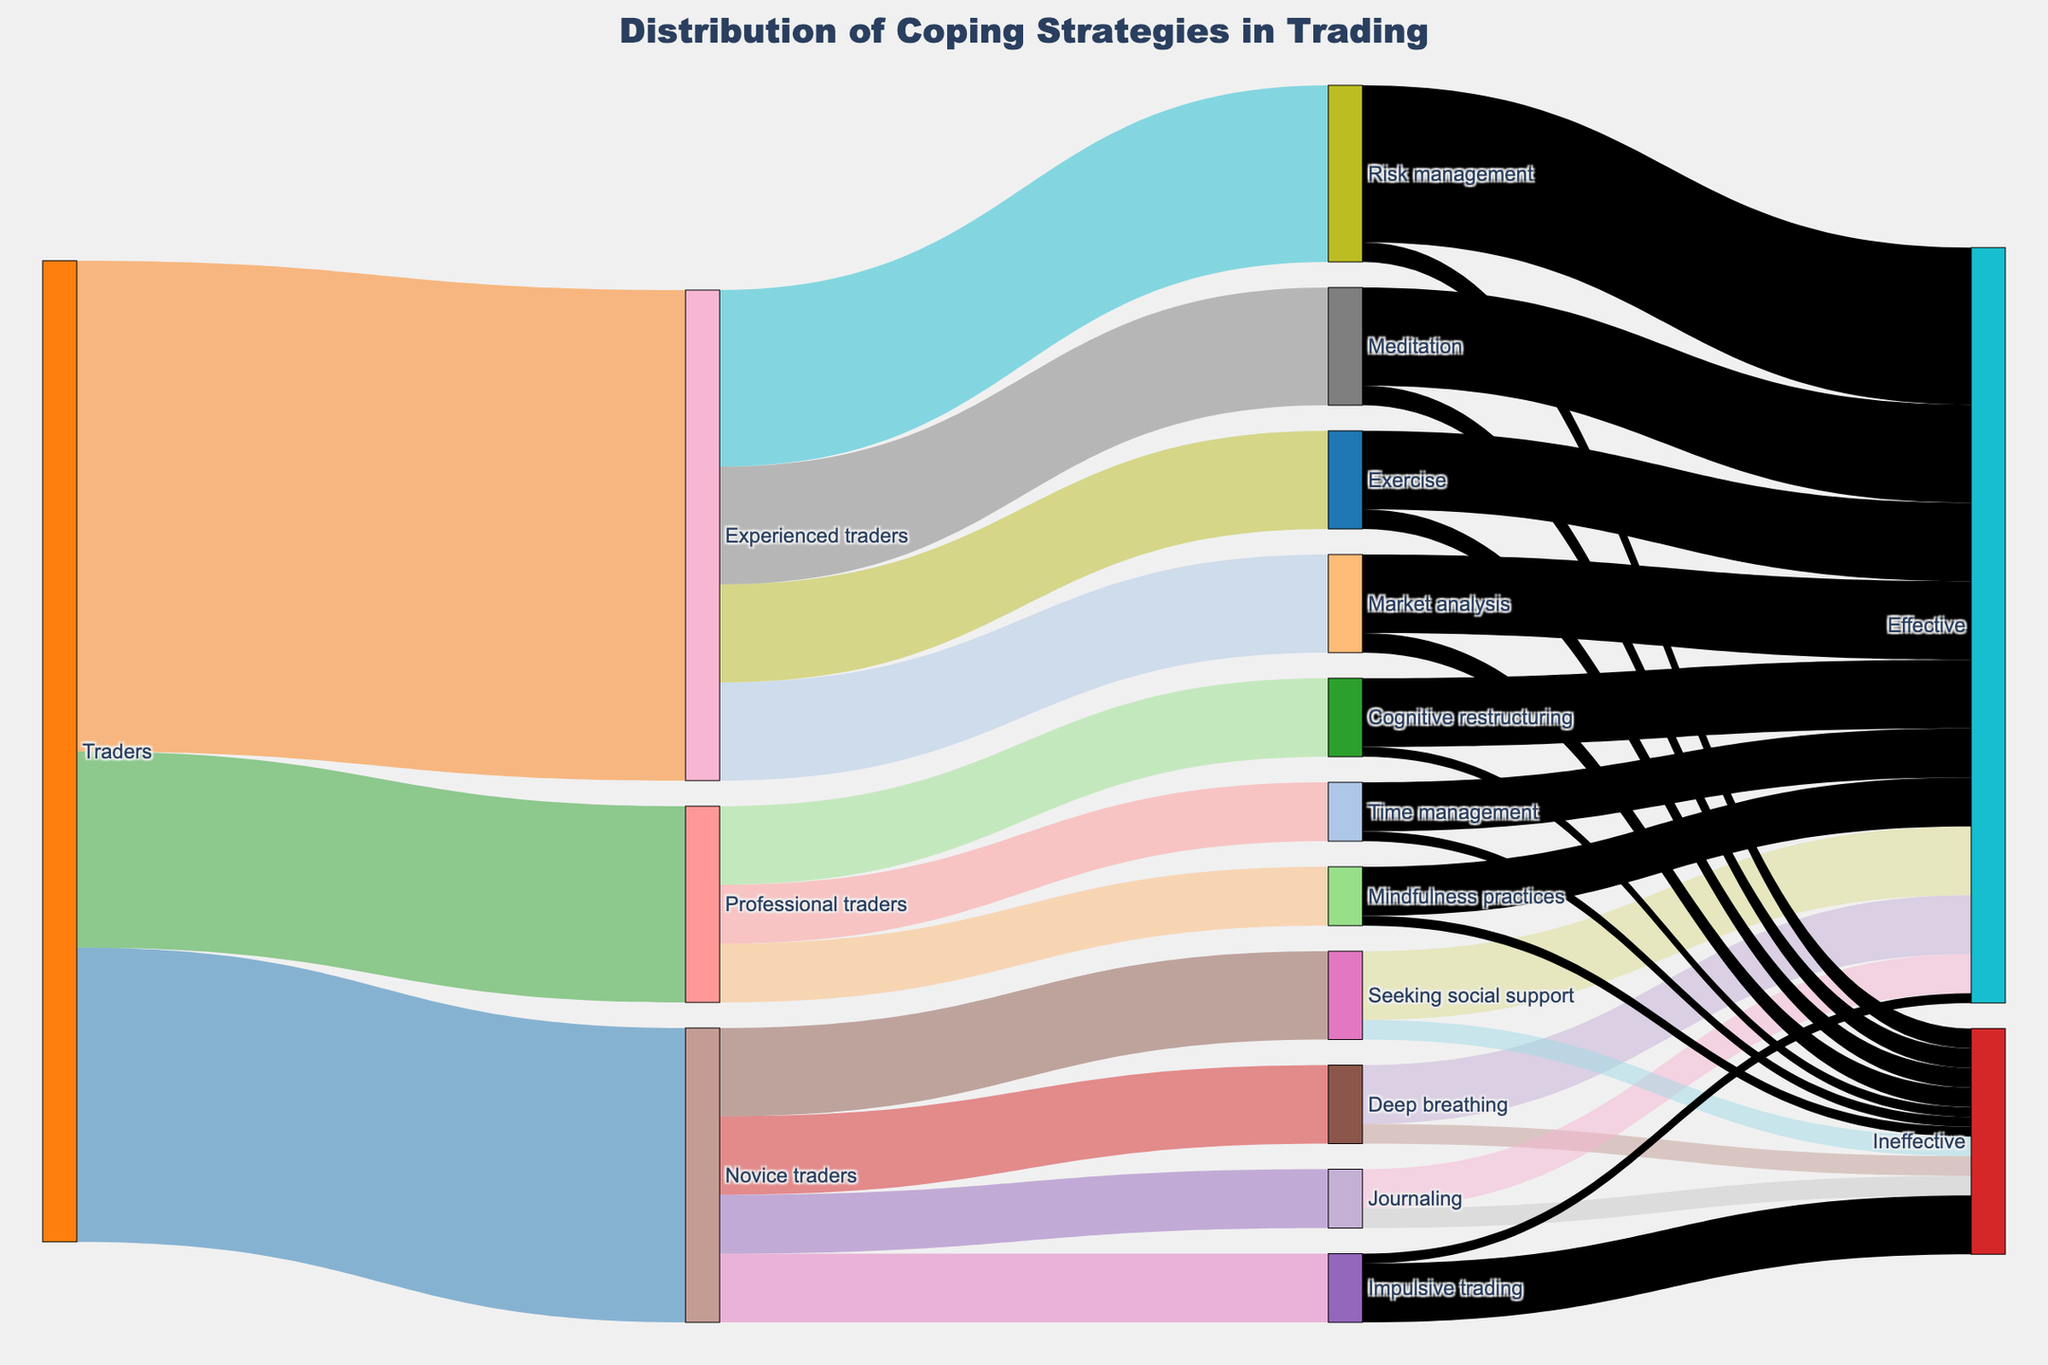what is the main title of the figure? The main title is displayed prominently at the top of the figure, reading "Distribution of Coping Strategies in Trading".
Answer: Distribution of Coping Strategies in Trading Which group of traders uses the "Risk management" coping strategy the most? The traders are segmented into Novice, Experienced, and Professional. The figure shows links between these groups and their coping strategies. The "Risk management" strategy is connected to Experienced traders with a value of 180, which is more than any other strategy for this trader type.
Answer: Experienced traders How many coping strategies are evaluated in the figure? By counting the unique coping strategies connected to each trader segment, we find: Deep breathing, Journaling, Seeking social support, Impulsive trading, Meditation, Exercise, Risk management, Market analysis, Mindfulness practices, Cognitive restructuring, and Time management, totaling 11.
Answer: 11 What portion of "Impulsive trading" among novice traders is categorized as ineffective? From the figure, 70 novice traders use "Impulsive trading". The portion that is ineffective is shown as 60. To find the percentage, calculate 60/70 ≈ 85.71%.
Answer: 85.71% Which coping strategy is deemed the most effective by experienced traders? Looking at the effective portions linked from experienced traders to coping strategies, "Risk management" has the highest value at 160.
Answer: Risk management How does the effectiveness of "Journaling" compare to "Seeking social support" for novice traders? Both strategies are used by novice traders. "Journaling" is effective for 40 out of 60 users, while "Seeking social support" is effective for 70 out of 90 users. Calculating effectiveness, "Journaling" has 40/60 = 66.67%, and "Seeking social support" has 70/90 ≈ 77.78%. Hence, "Seeking social support" is more effective.
Answer: Seeking social support What is the total number of novice traders who use effective coping strategies? The effective users for novice strategies can be counted: 60 for "Deep breathing", 40 for "Journaling", 70 for "Seeking social support", 10 for "Impulsive trading". Summing these values: 60 + 40 + 70 + 10 = 180.
Answer: 180 